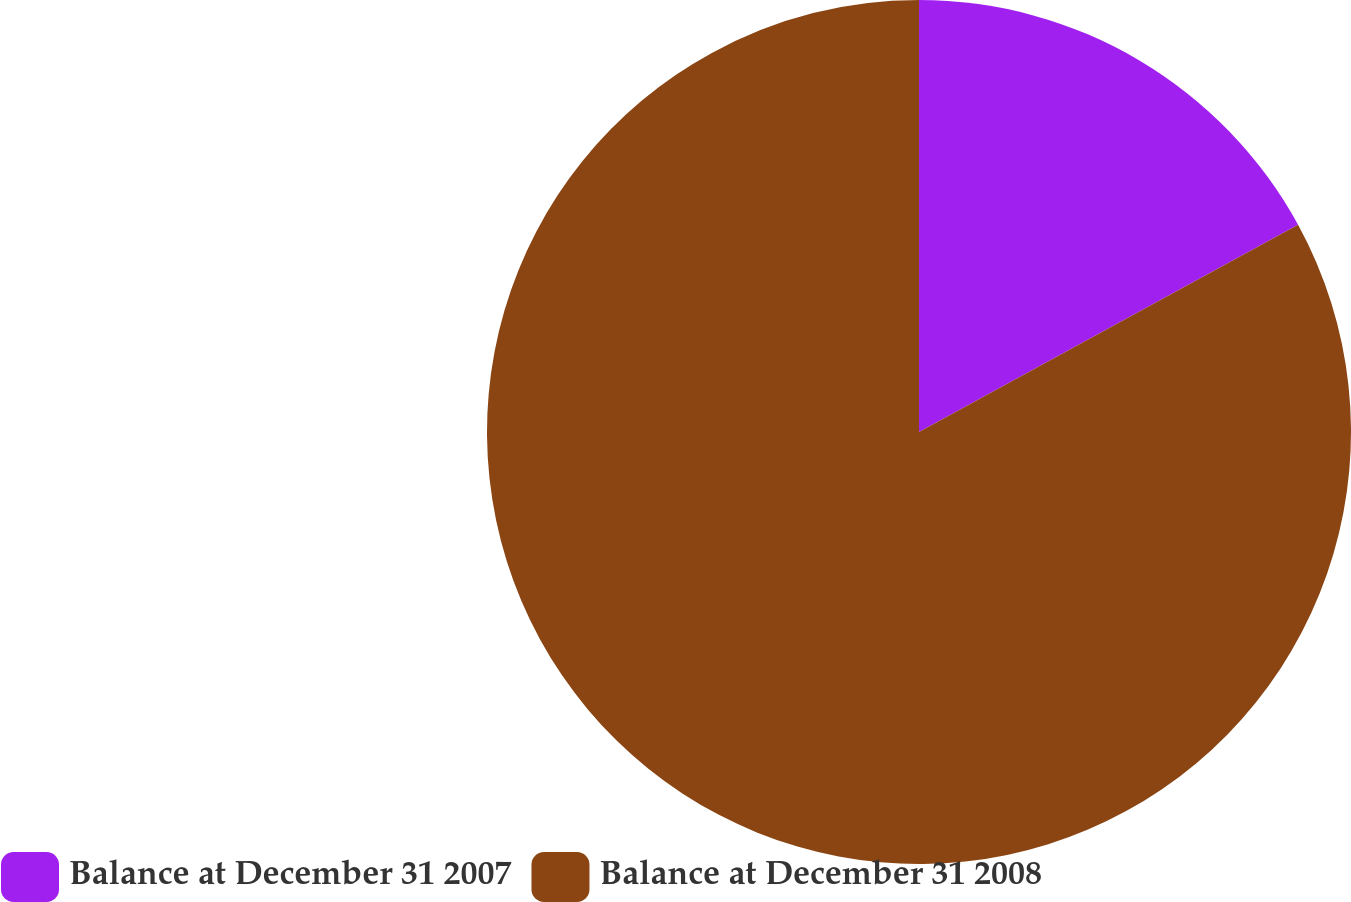<chart> <loc_0><loc_0><loc_500><loc_500><pie_chart><fcel>Balance at December 31 2007<fcel>Balance at December 31 2008<nl><fcel>17.04%<fcel>82.96%<nl></chart> 